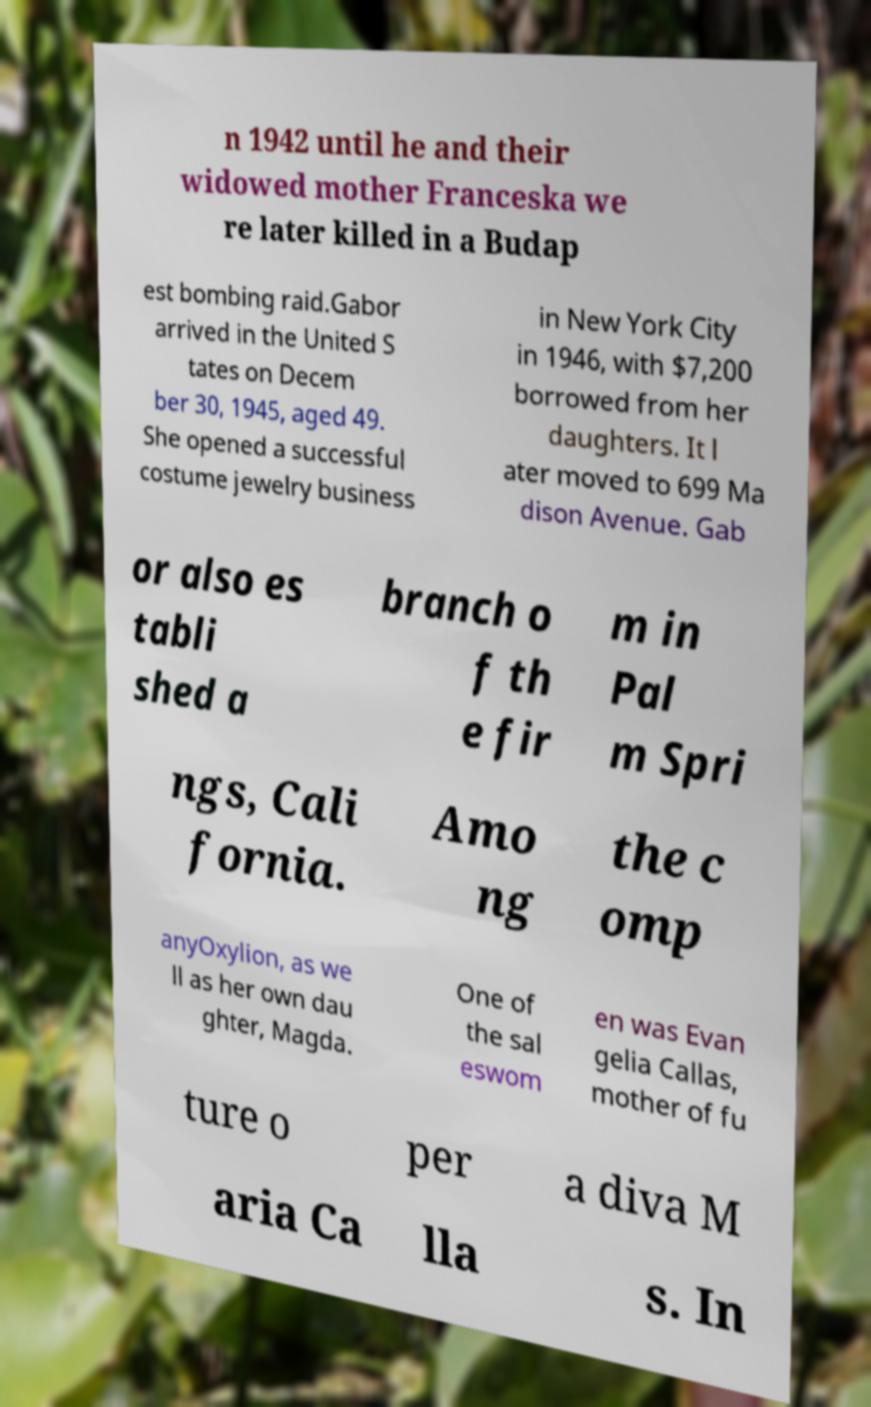Could you extract and type out the text from this image? n 1942 until he and their widowed mother Franceska we re later killed in a Budap est bombing raid.Gabor arrived in the United S tates on Decem ber 30, 1945, aged 49. She opened a successful costume jewelry business in New York City in 1946, with $7,200 borrowed from her daughters. It l ater moved to 699 Ma dison Avenue. Gab or also es tabli shed a branch o f th e fir m in Pal m Spri ngs, Cali fornia. Amo ng the c omp anyOxylion, as we ll as her own dau ghter, Magda. One of the sal eswom en was Evan gelia Callas, mother of fu ture o per a diva M aria Ca lla s. In 